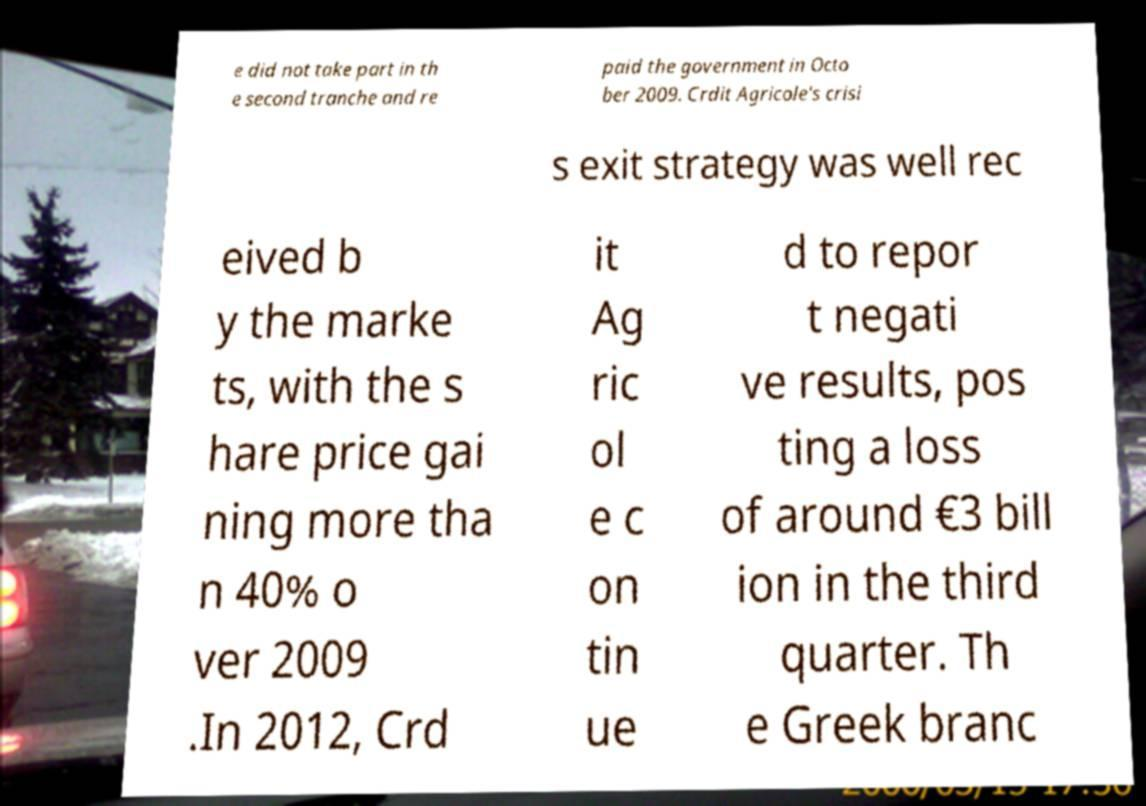Could you extract and type out the text from this image? e did not take part in th e second tranche and re paid the government in Octo ber 2009. Crdit Agricole's crisi s exit strategy was well rec eived b y the marke ts, with the s hare price gai ning more tha n 40% o ver 2009 .In 2012, Crd it Ag ric ol e c on tin ue d to repor t negati ve results, pos ting a loss of around €3 bill ion in the third quarter. Th e Greek branc 